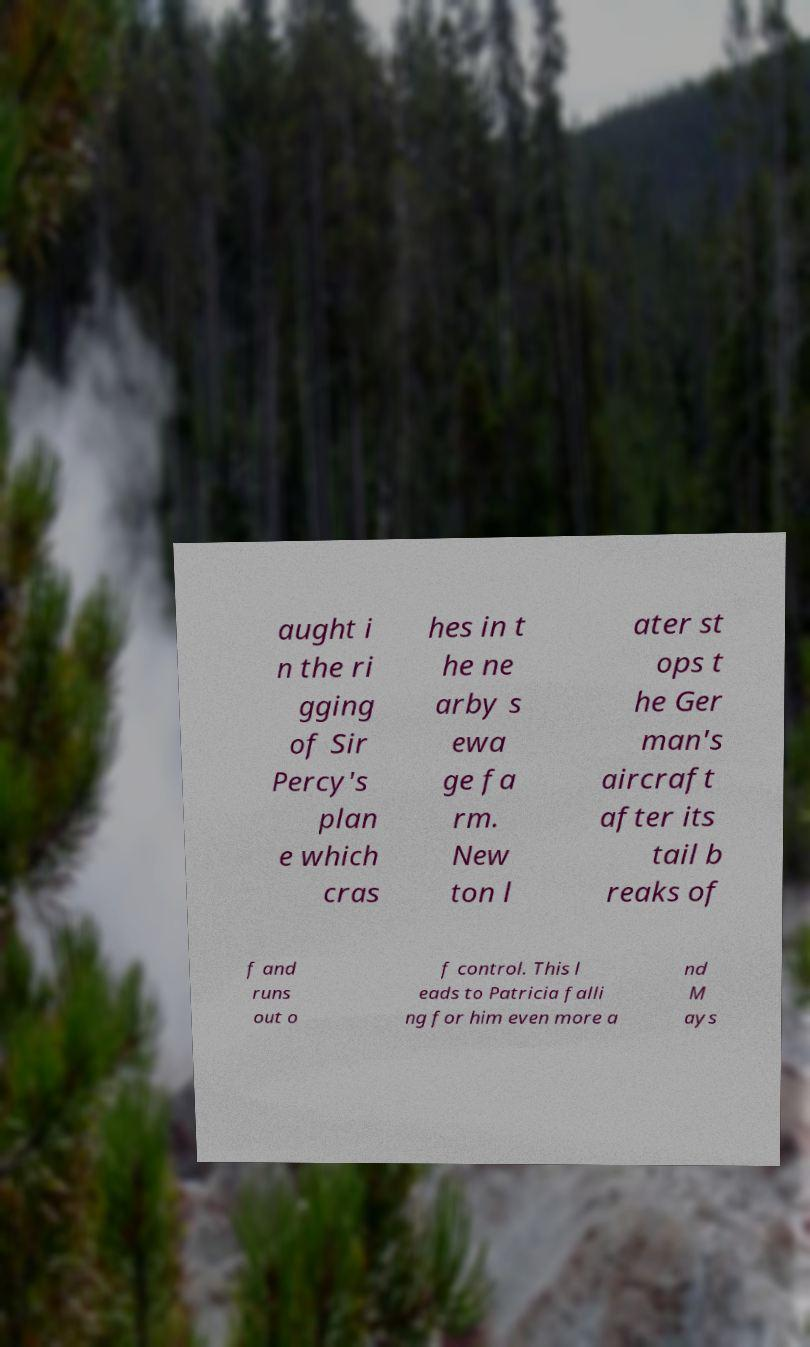I need the written content from this picture converted into text. Can you do that? aught i n the ri gging of Sir Percy's plan e which cras hes in t he ne arby s ewa ge fa rm. New ton l ater st ops t he Ger man's aircraft after its tail b reaks of f and runs out o f control. This l eads to Patricia falli ng for him even more a nd M ays 